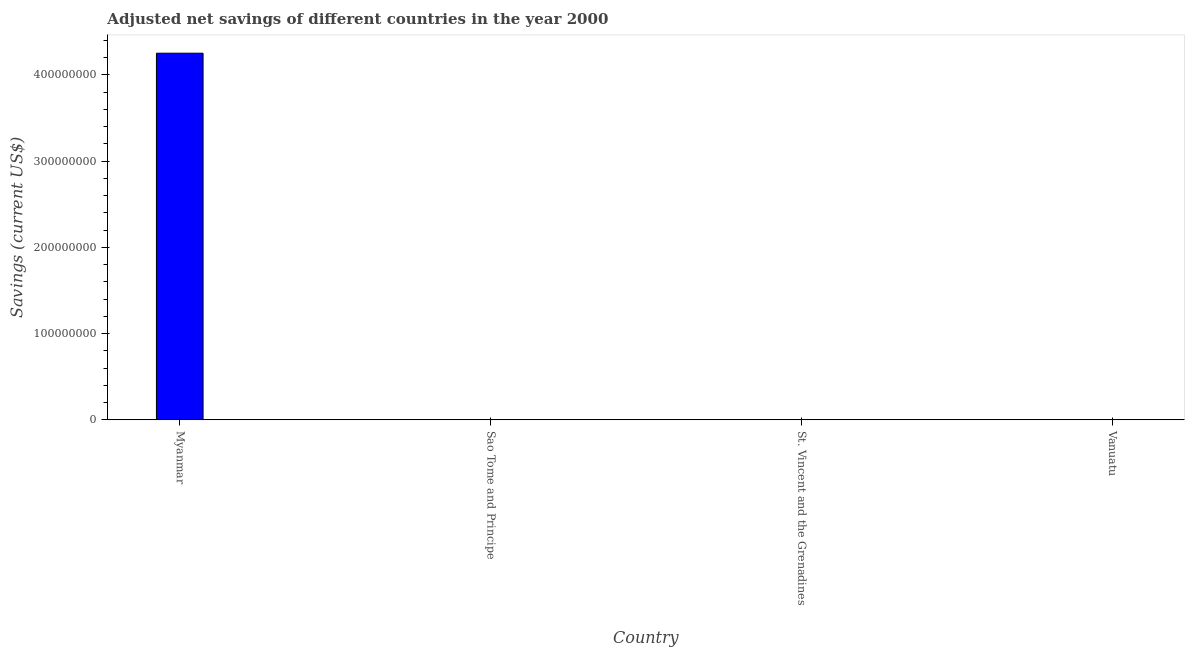Does the graph contain any zero values?
Your answer should be compact. No. What is the title of the graph?
Offer a very short reply. Adjusted net savings of different countries in the year 2000. What is the label or title of the X-axis?
Your response must be concise. Country. What is the label or title of the Y-axis?
Ensure brevity in your answer.  Savings (current US$). What is the adjusted net savings in Sao Tome and Principe?
Your response must be concise. 1901.31. Across all countries, what is the maximum adjusted net savings?
Keep it short and to the point. 4.25e+08. Across all countries, what is the minimum adjusted net savings?
Provide a short and direct response. 1901.31. In which country was the adjusted net savings maximum?
Your response must be concise. Myanmar. In which country was the adjusted net savings minimum?
Offer a very short reply. Sao Tome and Principe. What is the sum of the adjusted net savings?
Give a very brief answer. 4.25e+08. What is the difference between the adjusted net savings in Myanmar and Sao Tome and Principe?
Keep it short and to the point. 4.25e+08. What is the average adjusted net savings per country?
Give a very brief answer. 1.06e+08. What is the median adjusted net savings?
Provide a succinct answer. 1.63e+05. In how many countries, is the adjusted net savings greater than 340000000 US$?
Offer a terse response. 1. What is the ratio of the adjusted net savings in Myanmar to that in Sao Tome and Principe?
Offer a very short reply. 2.24e+05. What is the difference between the highest and the second highest adjusted net savings?
Your answer should be very brief. 4.25e+08. What is the difference between the highest and the lowest adjusted net savings?
Make the answer very short. 4.25e+08. In how many countries, is the adjusted net savings greater than the average adjusted net savings taken over all countries?
Provide a succinct answer. 1. How many bars are there?
Your answer should be compact. 4. Are the values on the major ticks of Y-axis written in scientific E-notation?
Ensure brevity in your answer.  No. What is the Savings (current US$) in Myanmar?
Your response must be concise. 4.25e+08. What is the Savings (current US$) of Sao Tome and Principe?
Keep it short and to the point. 1901.31. What is the Savings (current US$) of St. Vincent and the Grenadines?
Offer a terse response. 4.99e+04. What is the Savings (current US$) in Vanuatu?
Ensure brevity in your answer.  2.76e+05. What is the difference between the Savings (current US$) in Myanmar and Sao Tome and Principe?
Your answer should be compact. 4.25e+08. What is the difference between the Savings (current US$) in Myanmar and St. Vincent and the Grenadines?
Offer a terse response. 4.25e+08. What is the difference between the Savings (current US$) in Myanmar and Vanuatu?
Make the answer very short. 4.25e+08. What is the difference between the Savings (current US$) in Sao Tome and Principe and St. Vincent and the Grenadines?
Keep it short and to the point. -4.80e+04. What is the difference between the Savings (current US$) in Sao Tome and Principe and Vanuatu?
Your answer should be compact. -2.74e+05. What is the difference between the Savings (current US$) in St. Vincent and the Grenadines and Vanuatu?
Your response must be concise. -2.26e+05. What is the ratio of the Savings (current US$) in Myanmar to that in Sao Tome and Principe?
Offer a very short reply. 2.24e+05. What is the ratio of the Savings (current US$) in Myanmar to that in St. Vincent and the Grenadines?
Make the answer very short. 8510.88. What is the ratio of the Savings (current US$) in Myanmar to that in Vanuatu?
Provide a short and direct response. 1541.88. What is the ratio of the Savings (current US$) in Sao Tome and Principe to that in St. Vincent and the Grenadines?
Provide a short and direct response. 0.04. What is the ratio of the Savings (current US$) in Sao Tome and Principe to that in Vanuatu?
Make the answer very short. 0.01. What is the ratio of the Savings (current US$) in St. Vincent and the Grenadines to that in Vanuatu?
Ensure brevity in your answer.  0.18. 